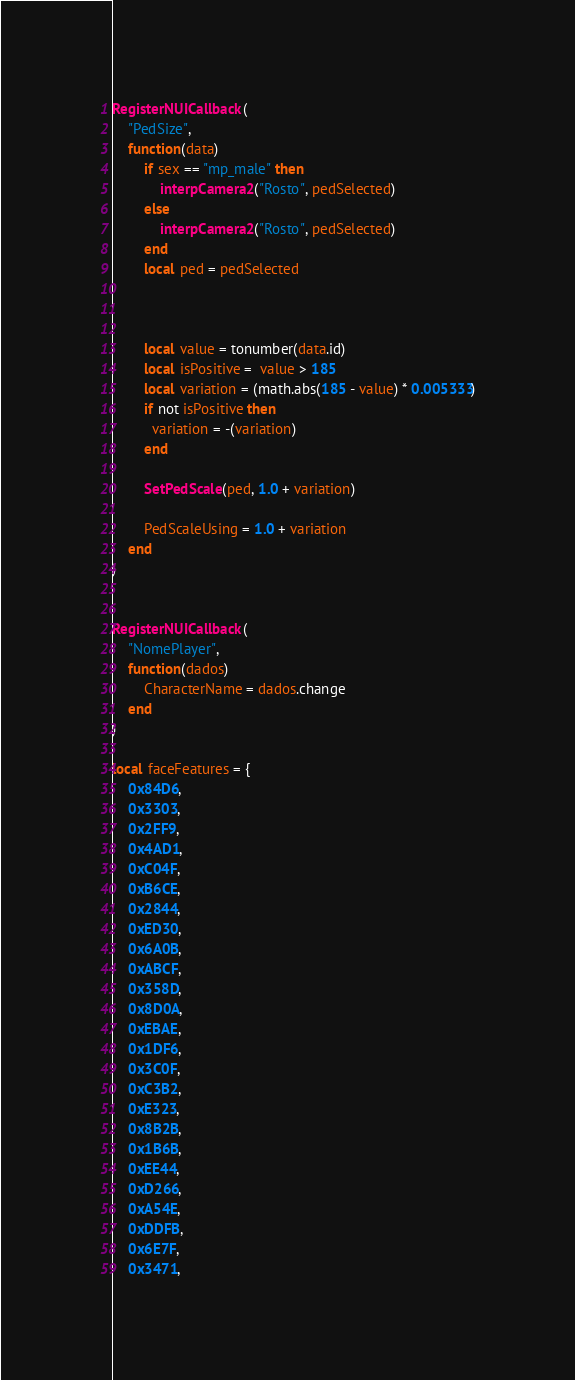Convert code to text. <code><loc_0><loc_0><loc_500><loc_500><_Lua_>RegisterNUICallback(
    "PedSize",
    function(data)
        if sex == "mp_male" then
            interpCamera2("Rosto", pedSelected)   
        else
            interpCamera2("Rosto", pedSelected)   
        end
        local ped = pedSelected



        local value = tonumber(data.id)
        local isPositive =  value > 185
        local variation = (math.abs(185 - value) * 0.005333)
        if not isPositive then 
          variation = -(variation)
        end

        SetPedScale(ped, 1.0 + variation)

        PedScaleUsing = 1.0 + variation
    end
)


RegisterNUICallback(
    "NomePlayer",
    function(dados)
        CharacterName = dados.change
    end
)

local faceFeatures = {
    0x84D6,
    0x3303,
    0x2FF9,
    0x4AD1,
    0xC04F,
    0xB6CE,
    0x2844,
    0xED30,
    0x6A0B,
    0xABCF,
    0x358D,
    0x8D0A,
    0xEBAE,
    0x1DF6,
    0x3C0F,
    0xC3B2,
    0xE323,
    0x8B2B,
    0x1B6B,
    0xEE44,
    0xD266,
    0xA54E,
    0xDDFB,
    0x6E7F,
    0x3471,</code> 